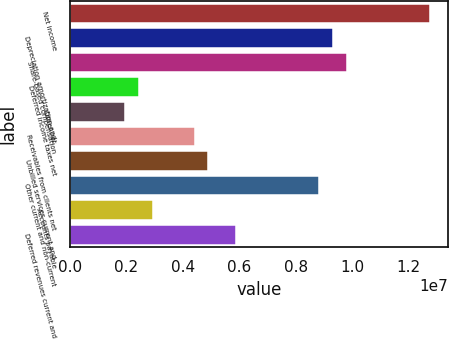Convert chart. <chart><loc_0><loc_0><loc_500><loc_500><bar_chart><fcel>Net income<fcel>Depreciation amortization and<fcel>Share-based compensation<fcel>Deferred income taxes net<fcel>Other net<fcel>Receivables from clients net<fcel>Unbilled services current and<fcel>Other current and non-current<fcel>Accounts payable<fcel>Deferred revenues current and<nl><fcel>1.27529e+07<fcel>9.3197e+06<fcel>9.81016e+06<fcel>2.45333e+06<fcel>1.96288e+06<fcel>4.41515e+06<fcel>4.90561e+06<fcel>8.82925e+06<fcel>2.94379e+06<fcel>5.88652e+06<nl></chart> 